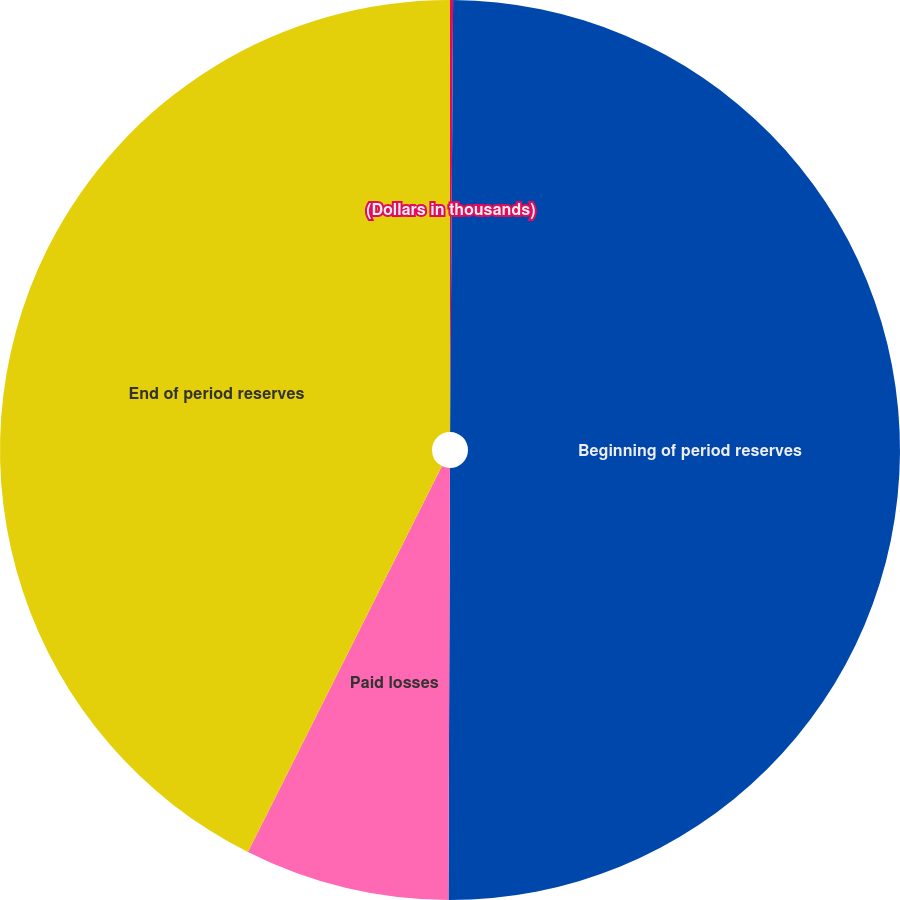Convert chart. <chart><loc_0><loc_0><loc_500><loc_500><pie_chart><fcel>(Dollars in thousands)<fcel>Beginning of period reserves<fcel>Paid losses<fcel>End of period reserves<nl><fcel>0.11%<fcel>49.95%<fcel>7.36%<fcel>42.59%<nl></chart> 